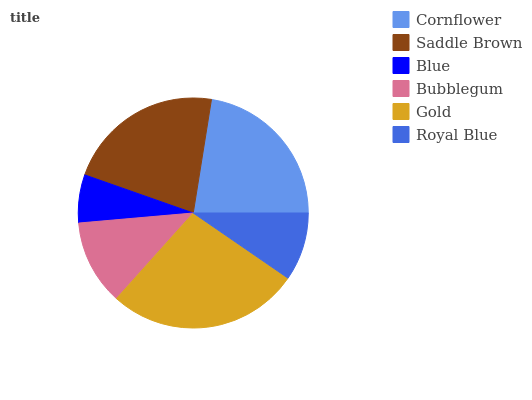Is Blue the minimum?
Answer yes or no. Yes. Is Gold the maximum?
Answer yes or no. Yes. Is Saddle Brown the minimum?
Answer yes or no. No. Is Saddle Brown the maximum?
Answer yes or no. No. Is Cornflower greater than Saddle Brown?
Answer yes or no. Yes. Is Saddle Brown less than Cornflower?
Answer yes or no. Yes. Is Saddle Brown greater than Cornflower?
Answer yes or no. No. Is Cornflower less than Saddle Brown?
Answer yes or no. No. Is Saddle Brown the high median?
Answer yes or no. Yes. Is Bubblegum the low median?
Answer yes or no. Yes. Is Blue the high median?
Answer yes or no. No. Is Blue the low median?
Answer yes or no. No. 